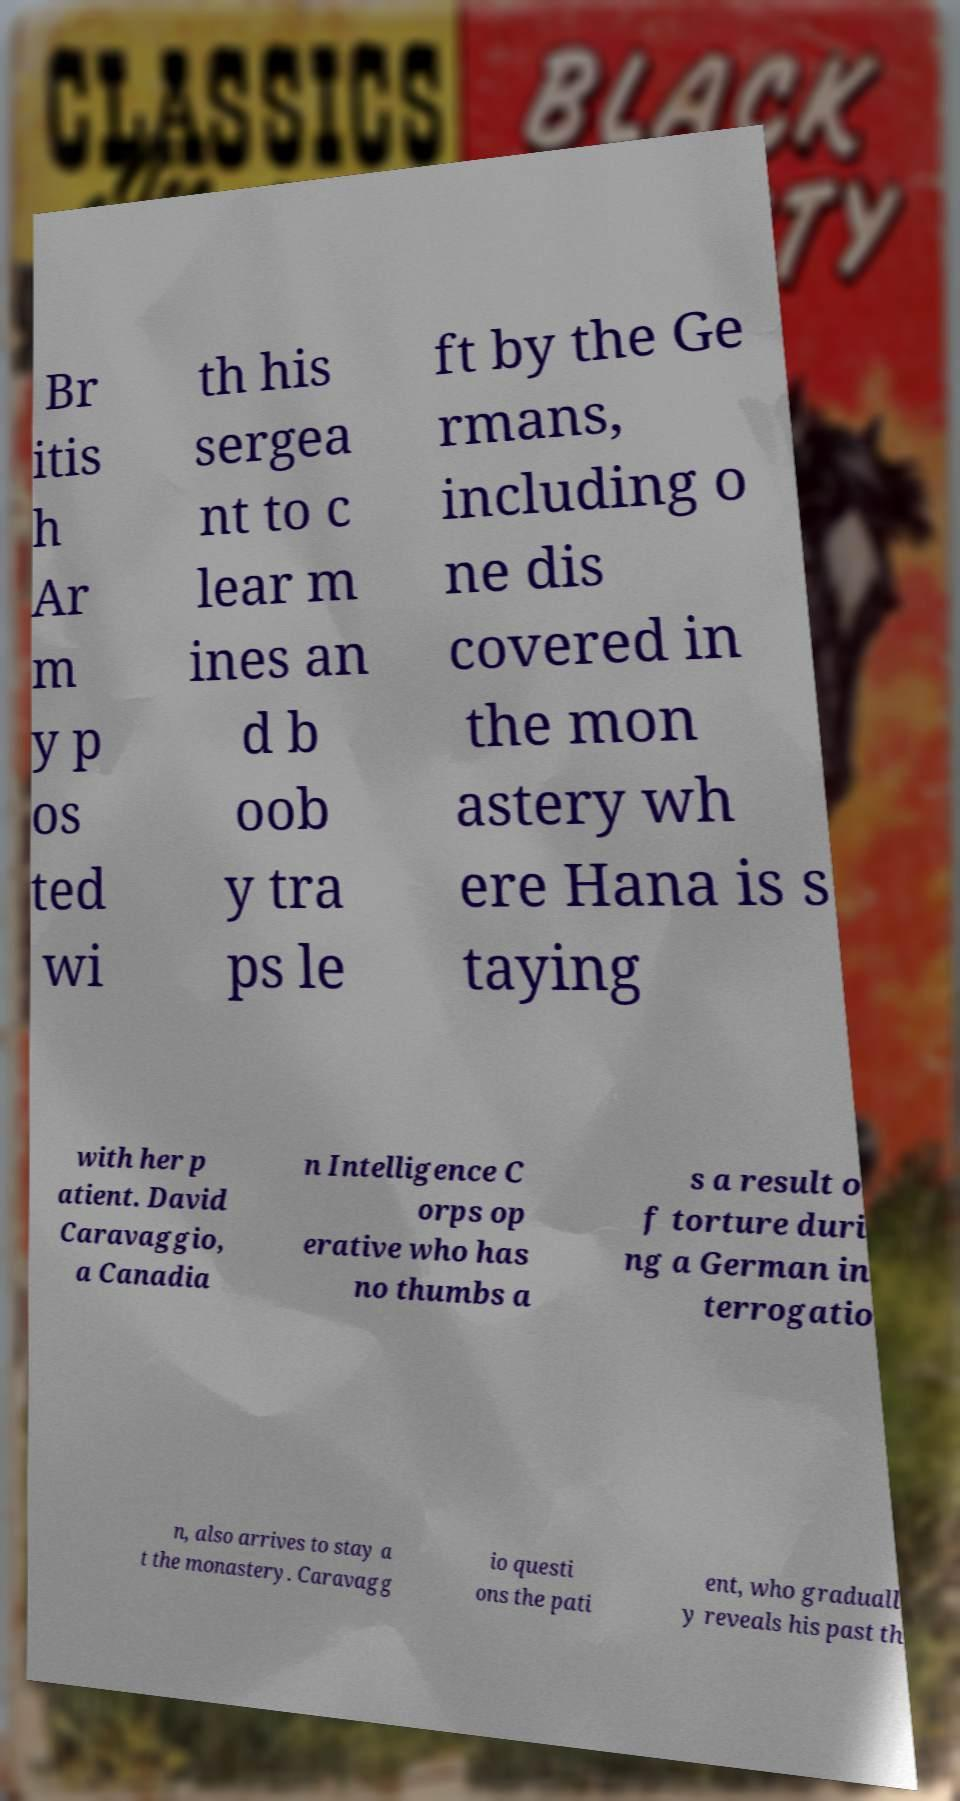Please identify and transcribe the text found in this image. Br itis h Ar m y p os ted wi th his sergea nt to c lear m ines an d b oob y tra ps le ft by the Ge rmans, including o ne dis covered in the mon astery wh ere Hana is s taying with her p atient. David Caravaggio, a Canadia n Intelligence C orps op erative who has no thumbs a s a result o f torture duri ng a German in terrogatio n, also arrives to stay a t the monastery. Caravagg io questi ons the pati ent, who graduall y reveals his past th 